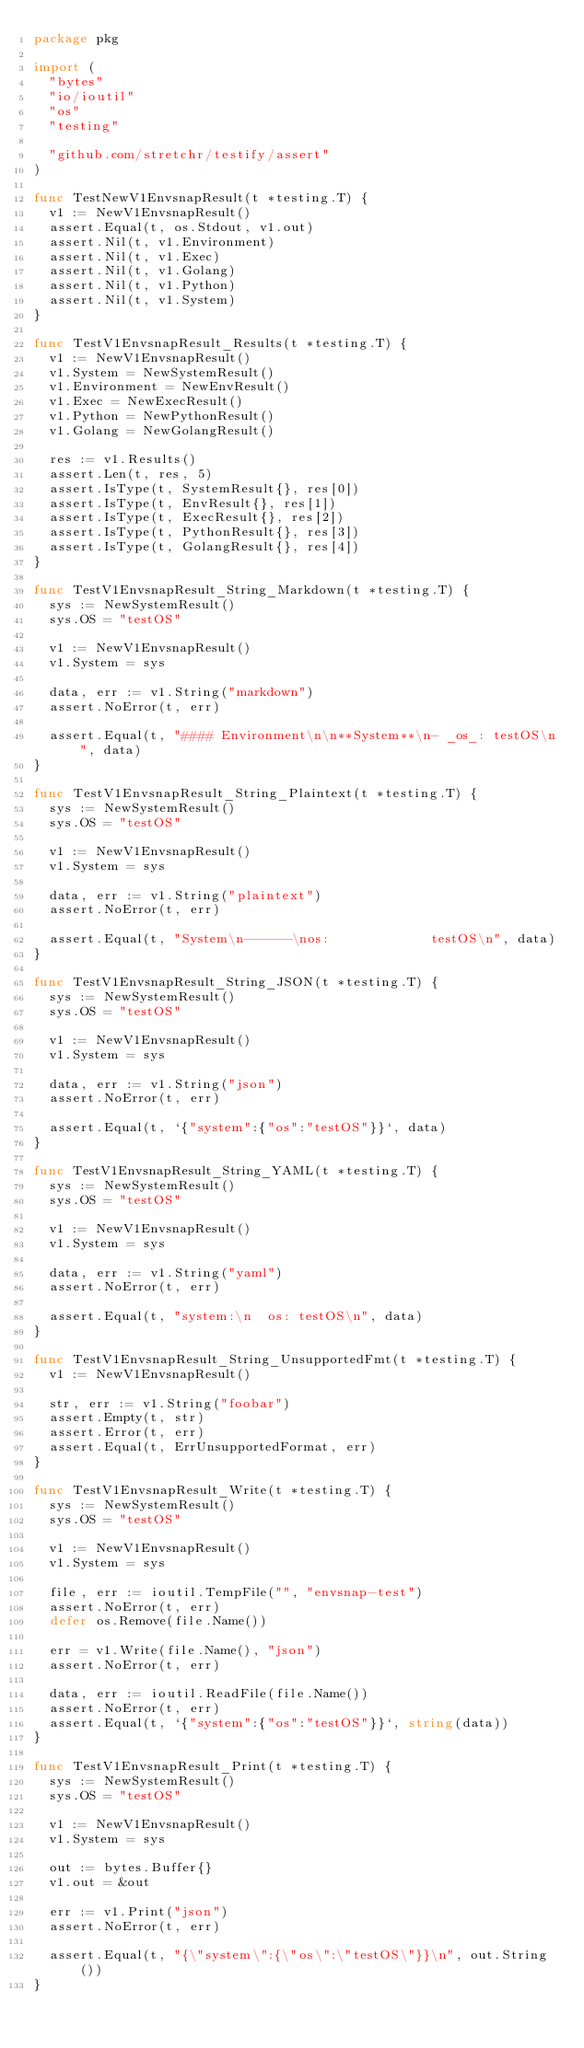Convert code to text. <code><loc_0><loc_0><loc_500><loc_500><_Go_>package pkg

import (
	"bytes"
	"io/ioutil"
	"os"
	"testing"

	"github.com/stretchr/testify/assert"
)

func TestNewV1EnvsnapResult(t *testing.T) {
	v1 := NewV1EnvsnapResult()
	assert.Equal(t, os.Stdout, v1.out)
	assert.Nil(t, v1.Environment)
	assert.Nil(t, v1.Exec)
	assert.Nil(t, v1.Golang)
	assert.Nil(t, v1.Python)
	assert.Nil(t, v1.System)
}

func TestV1EnvsnapResult_Results(t *testing.T) {
	v1 := NewV1EnvsnapResult()
	v1.System = NewSystemResult()
	v1.Environment = NewEnvResult()
	v1.Exec = NewExecResult()
	v1.Python = NewPythonResult()
	v1.Golang = NewGolangResult()

	res := v1.Results()
	assert.Len(t, res, 5)
	assert.IsType(t, SystemResult{}, res[0])
	assert.IsType(t, EnvResult{}, res[1])
	assert.IsType(t, ExecResult{}, res[2])
	assert.IsType(t, PythonResult{}, res[3])
	assert.IsType(t, GolangResult{}, res[4])
}

func TestV1EnvsnapResult_String_Markdown(t *testing.T) {
	sys := NewSystemResult()
	sys.OS = "testOS"

	v1 := NewV1EnvsnapResult()
	v1.System = sys

	data, err := v1.String("markdown")
	assert.NoError(t, err)

	assert.Equal(t, "#### Environment\n\n**System**\n- _os_: testOS\n", data)
}

func TestV1EnvsnapResult_String_Plaintext(t *testing.T) {
	sys := NewSystemResult()
	sys.OS = "testOS"

	v1 := NewV1EnvsnapResult()
	v1.System = sys

	data, err := v1.String("plaintext")
	assert.NoError(t, err)

	assert.Equal(t, "System\n------\nos:             testOS\n", data)
}

func TestV1EnvsnapResult_String_JSON(t *testing.T) {
	sys := NewSystemResult()
	sys.OS = "testOS"

	v1 := NewV1EnvsnapResult()
	v1.System = sys

	data, err := v1.String("json")
	assert.NoError(t, err)

	assert.Equal(t, `{"system":{"os":"testOS"}}`, data)
}

func TestV1EnvsnapResult_String_YAML(t *testing.T) {
	sys := NewSystemResult()
	sys.OS = "testOS"

	v1 := NewV1EnvsnapResult()
	v1.System = sys

	data, err := v1.String("yaml")
	assert.NoError(t, err)

	assert.Equal(t, "system:\n  os: testOS\n", data)
}

func TestV1EnvsnapResult_String_UnsupportedFmt(t *testing.T) {
	v1 := NewV1EnvsnapResult()

	str, err := v1.String("foobar")
	assert.Empty(t, str)
	assert.Error(t, err)
	assert.Equal(t, ErrUnsupportedFormat, err)
}

func TestV1EnvsnapResult_Write(t *testing.T) {
	sys := NewSystemResult()
	sys.OS = "testOS"

	v1 := NewV1EnvsnapResult()
	v1.System = sys

	file, err := ioutil.TempFile("", "envsnap-test")
	assert.NoError(t, err)
	defer os.Remove(file.Name())

	err = v1.Write(file.Name(), "json")
	assert.NoError(t, err)

	data, err := ioutil.ReadFile(file.Name())
	assert.NoError(t, err)
	assert.Equal(t, `{"system":{"os":"testOS"}}`, string(data))
}

func TestV1EnvsnapResult_Print(t *testing.T) {
	sys := NewSystemResult()
	sys.OS = "testOS"

	v1 := NewV1EnvsnapResult()
	v1.System = sys

	out := bytes.Buffer{}
	v1.out = &out

	err := v1.Print("json")
	assert.NoError(t, err)

	assert.Equal(t, "{\"system\":{\"os\":\"testOS\"}}\n", out.String())
}
</code> 